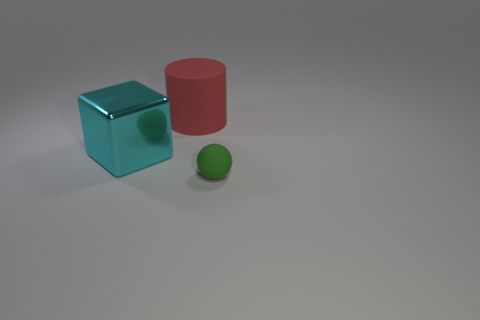There is a shiny object that is the same size as the red cylinder; what shape is it?
Offer a terse response. Cube. The red rubber cylinder has what size?
Your answer should be very brief. Large. What material is the large thing that is in front of the object that is behind the large thing that is in front of the red cylinder?
Ensure brevity in your answer.  Metal. There is a tiny sphere that is the same material as the red object; what is its color?
Keep it short and to the point. Green. What number of cyan blocks are behind the cyan metal object in front of the matte thing that is behind the small rubber ball?
Your answer should be compact. 0. Is there any other thing that is the same shape as the green thing?
Give a very brief answer. No. What number of things are either objects on the right side of the cyan metallic thing or big cyan shiny blocks?
Your answer should be compact. 3. What shape is the thing that is on the left side of the matte thing that is behind the tiny object?
Your answer should be very brief. Cube. Are there fewer cylinders behind the red rubber thing than big red things on the left side of the small rubber sphere?
Keep it short and to the point. Yes. Is there any other thing that has the same size as the green rubber sphere?
Your answer should be very brief. No. 